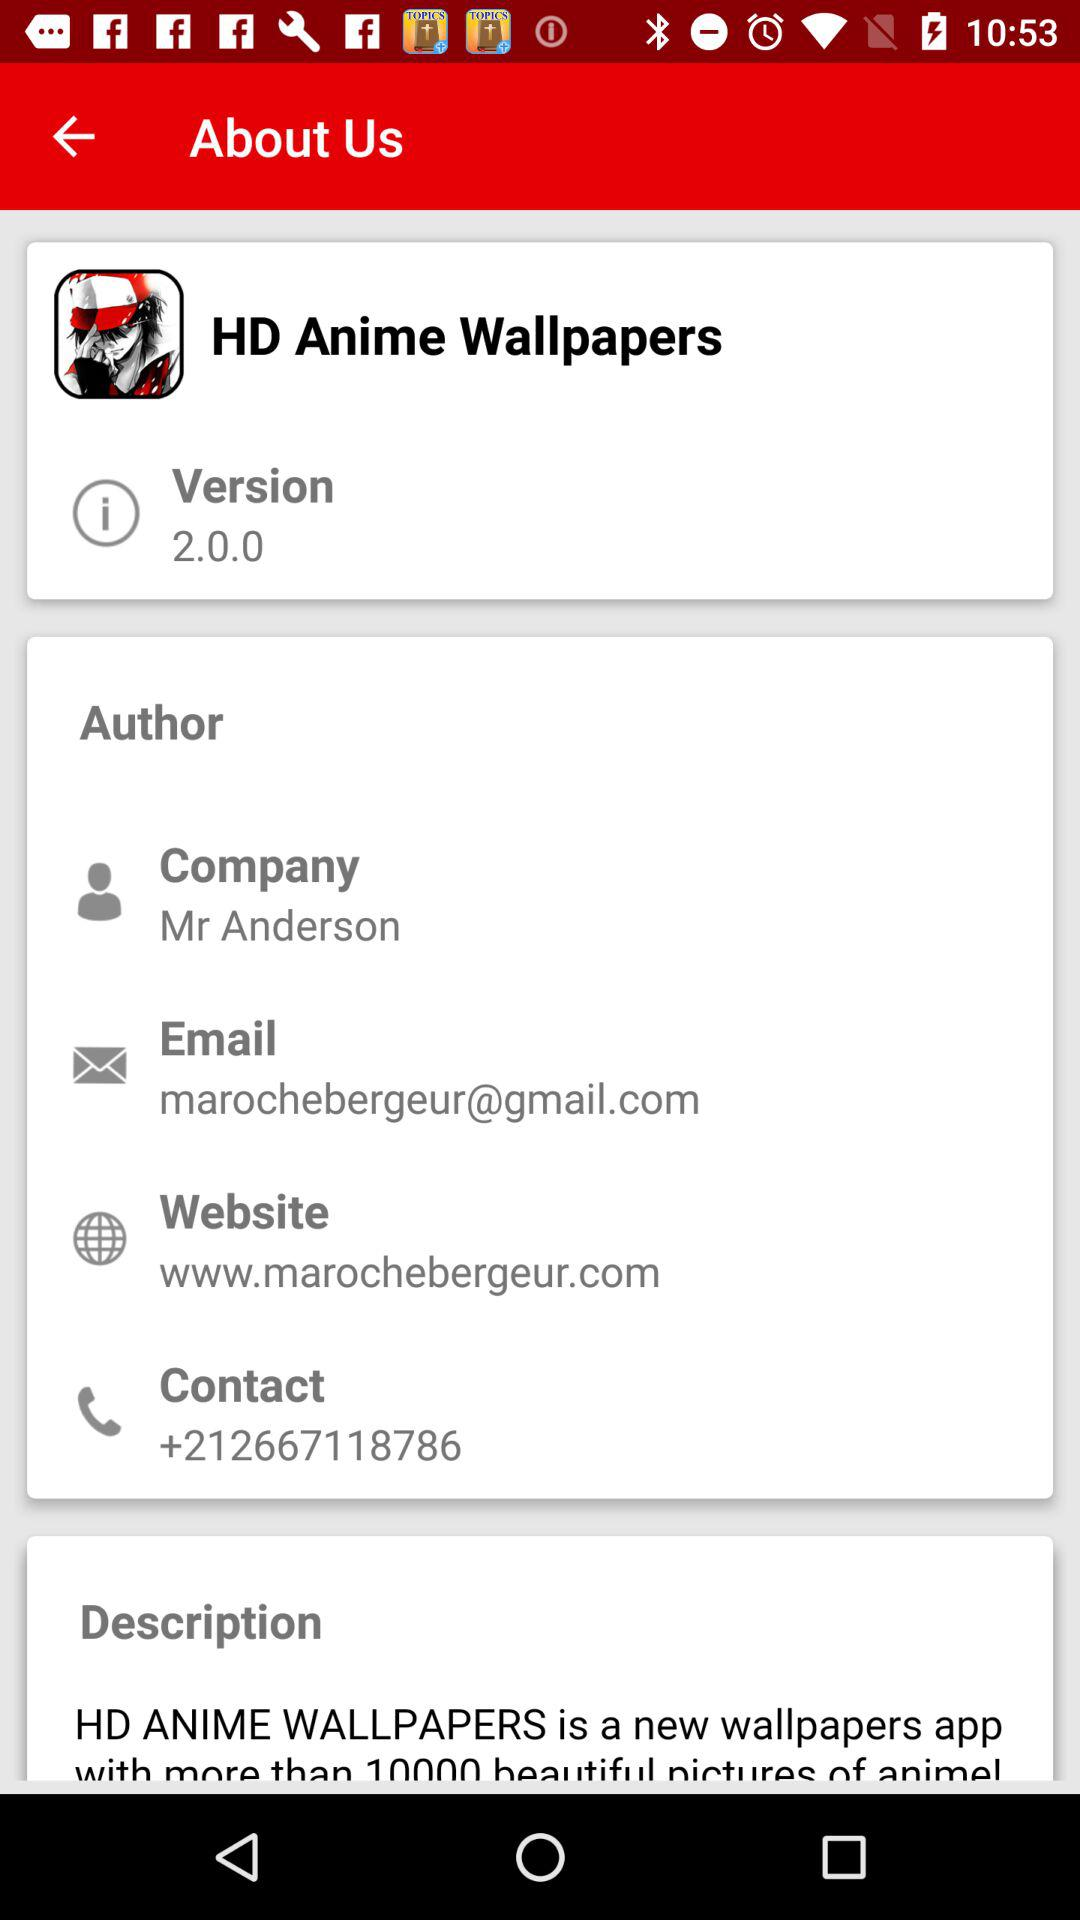What is the user name?
When the provided information is insufficient, respond with <no answer>. <no answer> 